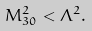Convert formula to latex. <formula><loc_0><loc_0><loc_500><loc_500>M ^ { 2 } _ { 3 0 } < \Lambda ^ { 2 } .</formula> 